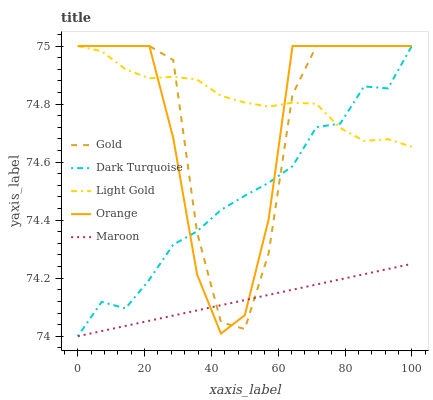Does Maroon have the minimum area under the curve?
Answer yes or no. Yes. Does Light Gold have the maximum area under the curve?
Answer yes or no. Yes. Does Dark Turquoise have the minimum area under the curve?
Answer yes or no. No. Does Dark Turquoise have the maximum area under the curve?
Answer yes or no. No. Is Maroon the smoothest?
Answer yes or no. Yes. Is Gold the roughest?
Answer yes or no. Yes. Is Dark Turquoise the smoothest?
Answer yes or no. No. Is Dark Turquoise the roughest?
Answer yes or no. No. Does Dark Turquoise have the lowest value?
Answer yes or no. Yes. Does Light Gold have the lowest value?
Answer yes or no. No. Does Gold have the highest value?
Answer yes or no. Yes. Does Maroon have the highest value?
Answer yes or no. No. Is Maroon less than Light Gold?
Answer yes or no. Yes. Is Light Gold greater than Maroon?
Answer yes or no. Yes. Does Dark Turquoise intersect Orange?
Answer yes or no. Yes. Is Dark Turquoise less than Orange?
Answer yes or no. No. Is Dark Turquoise greater than Orange?
Answer yes or no. No. Does Maroon intersect Light Gold?
Answer yes or no. No. 